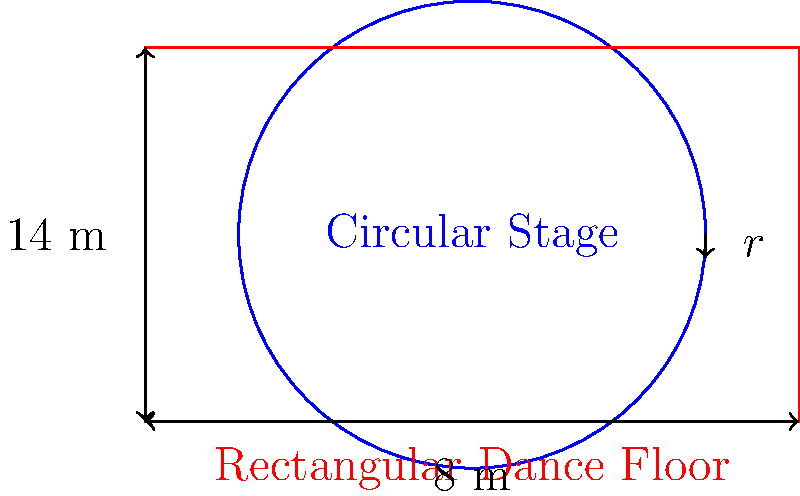Hey there, music lovers! It's your slightly bored DJ here, back with another mind-bending question. Remember when Alyx Ander performed on that cool circular stage? Well, imagine we've got a circular stage with a radius of $5$ meters, surrounded by a rectangular dance floor that's $14$ meters long and $8$ meters wide. Here's the million-dollar question: How much longer is the perimeter of the rectangular dance floor compared to the circumference of the circular stage? Round your answer to the nearest meter. Alright, let's break this down step by step:

1) First, let's calculate the circumference of the circular stage:
   Circumference = $2\pi r$
   where $r$ is the radius (5 meters)
   Circumference = $2\pi(5)$ = $10\pi$ meters

2) Now, let's find the perimeter of the rectangular dance floor:
   Perimeter = $2(length + width)$
   Perimeter = $2(14 + 8)$ = $2(22)$ = $44$ meters

3) To find how much longer the rectangular perimeter is:
   Difference = Rectangular Perimeter - Circular Circumference
   Difference = $44 - 10\pi$ meters

4) Let's calculate this:
   $44 - 10\pi$ ≈ $44 - 31.42$ = $12.58$ meters

5) Rounding to the nearest meter:
   $12.58$ rounds to $13$ meters

So, the perimeter of the rectangular dance floor is about 13 meters longer than the circumference of the circular stage.
Answer: $13$ meters 